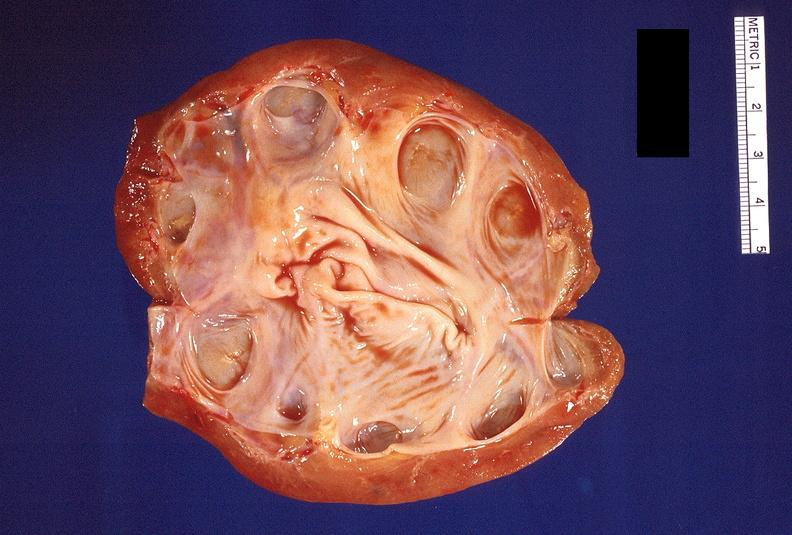what does this image show?
Answer the question using a single word or phrase. Hydronephrosis 